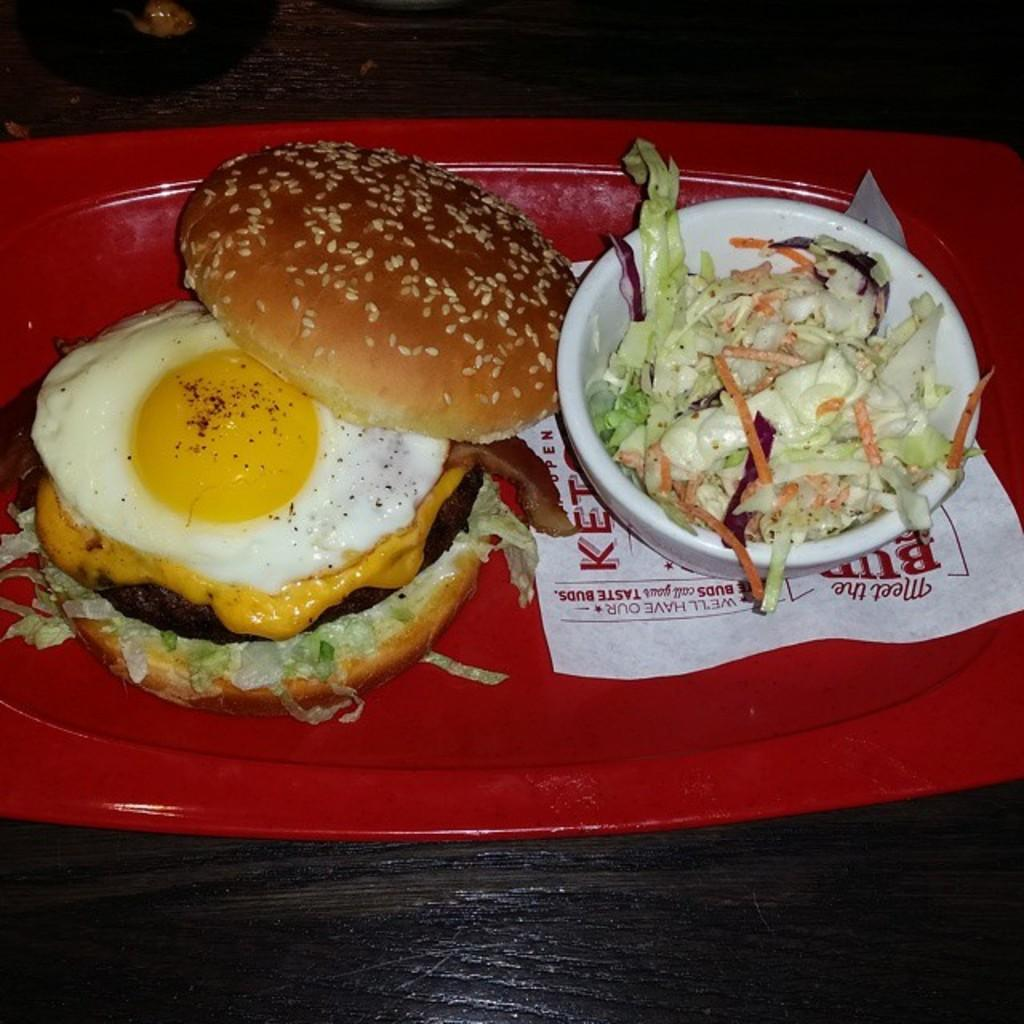What is the main subject of the image? The main subject of the image is a tray filled with food items. What type of ear is visible on the tray in the image? There is no ear present on the tray in the image. The image only shows a tray filled with food items. 